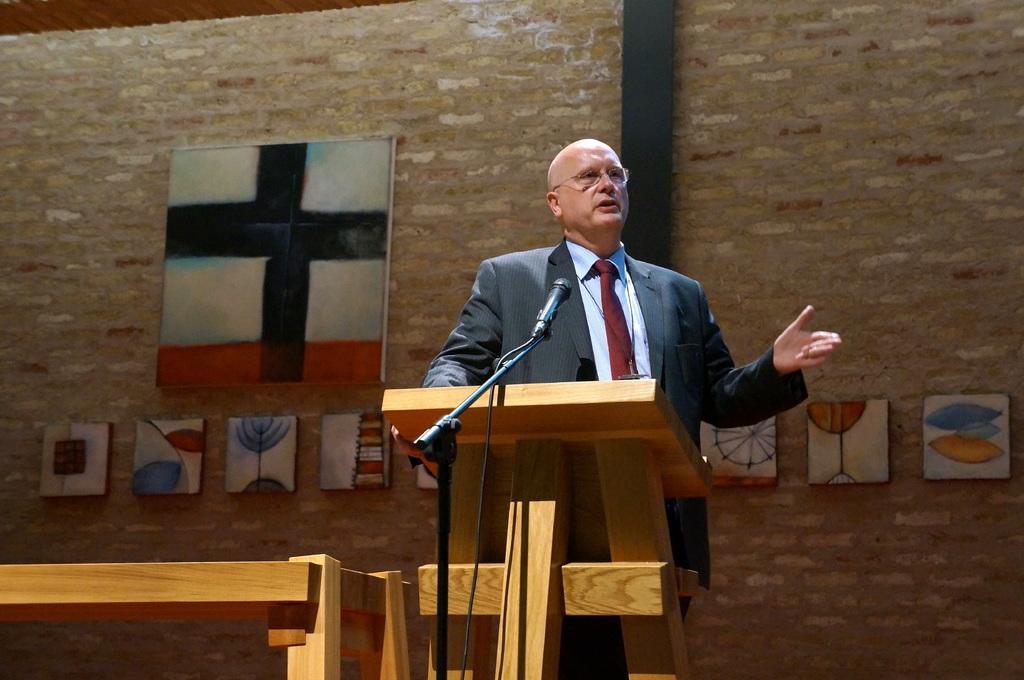Can you describe this image briefly? In this picture there is a man who is standing in front of a desk and a mic in the center of the image and there are portraits in the background area of the image. 